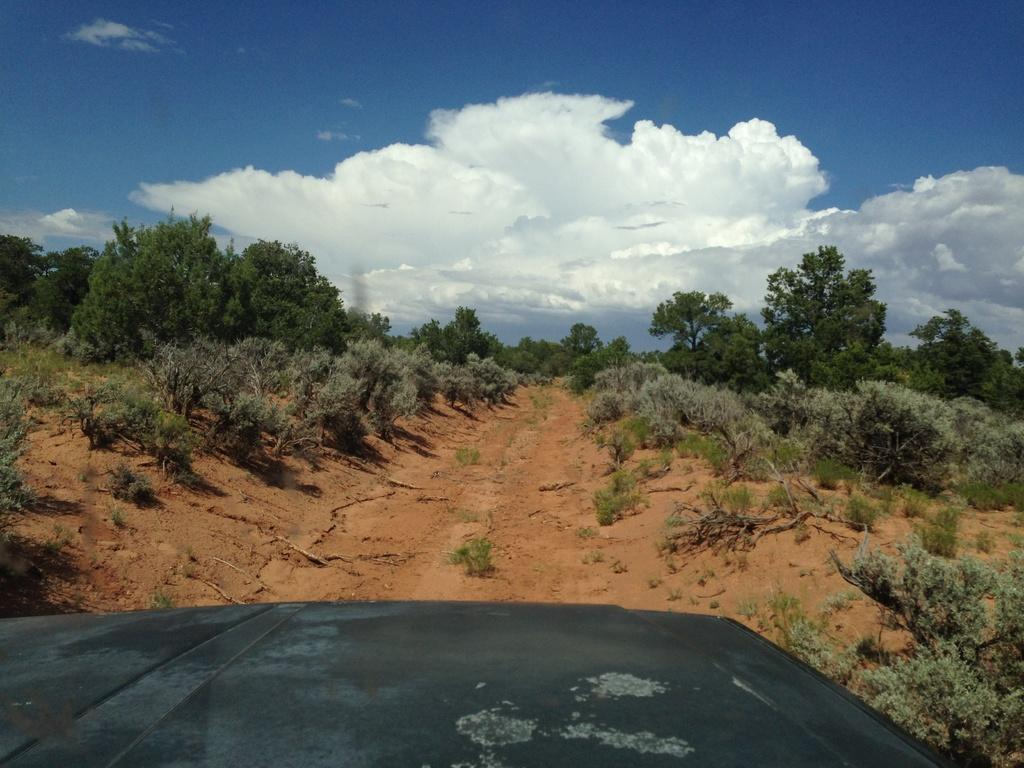What is the main subject of the image? There is a vehicle in the image. What can be seen on both sides of the vehicle? There are trees on both sides of the vehicle. What part of the environment is visible beneath the vehicle? The ground is visible in the image. What is the condition of the sky in the background of the image? The sky is cloudy in the background of the image. What type of roof can be seen on the vehicle in the image? There is no roof visible on the vehicle in the image, as it appears to be an open-air vehicle. What is the chin of the person driving the vehicle like in the image? There is no person driving the vehicle in the image, so it is not possible to describe their chin. 